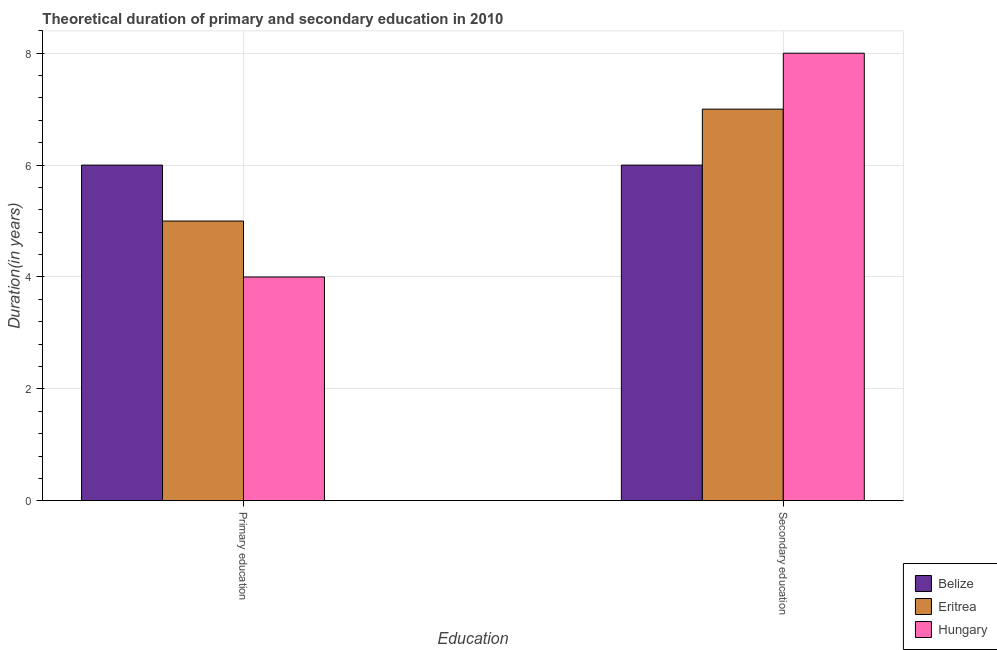How many different coloured bars are there?
Ensure brevity in your answer.  3. How many groups of bars are there?
Offer a terse response. 2. Are the number of bars on each tick of the X-axis equal?
Your response must be concise. Yes. How many bars are there on the 2nd tick from the left?
Provide a succinct answer. 3. What is the label of the 2nd group of bars from the left?
Make the answer very short. Secondary education. What is the duration of secondary education in Hungary?
Offer a very short reply. 8. Across all countries, what is the minimum duration of secondary education?
Your answer should be compact. 6. In which country was the duration of secondary education maximum?
Provide a short and direct response. Hungary. In which country was the duration of secondary education minimum?
Your answer should be very brief. Belize. What is the total duration of primary education in the graph?
Ensure brevity in your answer.  15. What is the difference between the duration of primary education in Eritrea and that in Belize?
Provide a succinct answer. -1. What is the difference between the duration of secondary education in Hungary and the duration of primary education in Belize?
Ensure brevity in your answer.  2. What is the average duration of secondary education per country?
Your answer should be compact. 7. What is the difference between the duration of secondary education and duration of primary education in Eritrea?
Your answer should be compact. 2. In how many countries, is the duration of secondary education greater than 2 years?
Your answer should be compact. 3. What is the ratio of the duration of secondary education in Hungary to that in Belize?
Your response must be concise. 1.33. In how many countries, is the duration of secondary education greater than the average duration of secondary education taken over all countries?
Ensure brevity in your answer.  1. What does the 1st bar from the left in Secondary education represents?
Give a very brief answer. Belize. What does the 1st bar from the right in Secondary education represents?
Make the answer very short. Hungary. How many bars are there?
Give a very brief answer. 6. Are all the bars in the graph horizontal?
Give a very brief answer. No. How many countries are there in the graph?
Offer a very short reply. 3. What is the difference between two consecutive major ticks on the Y-axis?
Provide a short and direct response. 2. Are the values on the major ticks of Y-axis written in scientific E-notation?
Keep it short and to the point. No. Does the graph contain grids?
Offer a terse response. Yes. How many legend labels are there?
Provide a short and direct response. 3. How are the legend labels stacked?
Ensure brevity in your answer.  Vertical. What is the title of the graph?
Offer a very short reply. Theoretical duration of primary and secondary education in 2010. Does "Bolivia" appear as one of the legend labels in the graph?
Provide a succinct answer. No. What is the label or title of the X-axis?
Give a very brief answer. Education. What is the label or title of the Y-axis?
Your answer should be very brief. Duration(in years). What is the Duration(in years) in Belize in Primary education?
Keep it short and to the point. 6. What is the Duration(in years) in Hungary in Primary education?
Your answer should be very brief. 4. What is the Duration(in years) in Belize in Secondary education?
Your answer should be very brief. 6. What is the Duration(in years) of Eritrea in Secondary education?
Ensure brevity in your answer.  7. What is the Duration(in years) of Hungary in Secondary education?
Ensure brevity in your answer.  8. Across all Education, what is the maximum Duration(in years) of Belize?
Make the answer very short. 6. What is the total Duration(in years) of Belize in the graph?
Give a very brief answer. 12. What is the total Duration(in years) in Eritrea in the graph?
Provide a short and direct response. 12. What is the difference between the Duration(in years) in Belize in Primary education and that in Secondary education?
Make the answer very short. 0. What is the difference between the Duration(in years) of Eritrea in Primary education and the Duration(in years) of Hungary in Secondary education?
Make the answer very short. -3. What is the average Duration(in years) of Eritrea per Education?
Make the answer very short. 6. What is the average Duration(in years) in Hungary per Education?
Your response must be concise. 6. What is the difference between the Duration(in years) in Belize and Duration(in years) in Eritrea in Primary education?
Ensure brevity in your answer.  1. What is the difference between the Duration(in years) in Belize and Duration(in years) in Hungary in Primary education?
Provide a succinct answer. 2. What is the difference between the Duration(in years) in Eritrea and Duration(in years) in Hungary in Primary education?
Your answer should be very brief. 1. What is the difference between the Duration(in years) in Belize and Duration(in years) in Hungary in Secondary education?
Offer a terse response. -2. What is the ratio of the Duration(in years) in Eritrea in Primary education to that in Secondary education?
Your answer should be compact. 0.71. What is the difference between the highest and the second highest Duration(in years) in Belize?
Your response must be concise. 0. What is the difference between the highest and the second highest Duration(in years) in Eritrea?
Offer a terse response. 2. What is the difference between the highest and the second highest Duration(in years) of Hungary?
Provide a succinct answer. 4. What is the difference between the highest and the lowest Duration(in years) in Belize?
Keep it short and to the point. 0. 